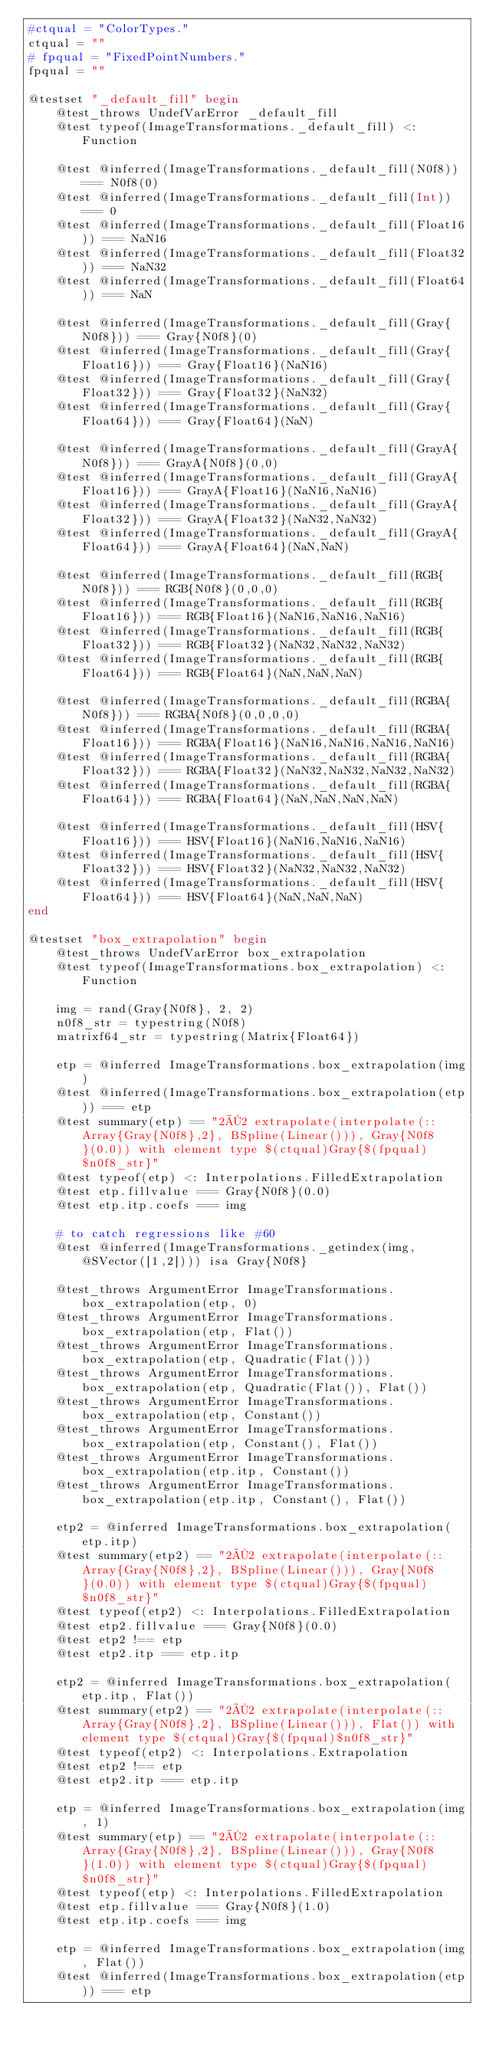<code> <loc_0><loc_0><loc_500><loc_500><_Julia_>#ctqual = "ColorTypes."
ctqual = ""
# fpqual = "FixedPointNumbers."
fpqual = ""

@testset "_default_fill" begin
    @test_throws UndefVarError _default_fill
    @test typeof(ImageTransformations._default_fill) <: Function

    @test @inferred(ImageTransformations._default_fill(N0f8)) === N0f8(0)
    @test @inferred(ImageTransformations._default_fill(Int)) === 0
    @test @inferred(ImageTransformations._default_fill(Float16)) === NaN16
    @test @inferred(ImageTransformations._default_fill(Float32)) === NaN32
    @test @inferred(ImageTransformations._default_fill(Float64)) === NaN

    @test @inferred(ImageTransformations._default_fill(Gray{N0f8})) === Gray{N0f8}(0)
    @test @inferred(ImageTransformations._default_fill(Gray{Float16})) === Gray{Float16}(NaN16)
    @test @inferred(ImageTransformations._default_fill(Gray{Float32})) === Gray{Float32}(NaN32)
    @test @inferred(ImageTransformations._default_fill(Gray{Float64})) === Gray{Float64}(NaN)

    @test @inferred(ImageTransformations._default_fill(GrayA{N0f8})) === GrayA{N0f8}(0,0)
    @test @inferred(ImageTransformations._default_fill(GrayA{Float16})) === GrayA{Float16}(NaN16,NaN16)
    @test @inferred(ImageTransformations._default_fill(GrayA{Float32})) === GrayA{Float32}(NaN32,NaN32)
    @test @inferred(ImageTransformations._default_fill(GrayA{Float64})) === GrayA{Float64}(NaN,NaN)

    @test @inferred(ImageTransformations._default_fill(RGB{N0f8})) === RGB{N0f8}(0,0,0)
    @test @inferred(ImageTransformations._default_fill(RGB{Float16})) === RGB{Float16}(NaN16,NaN16,NaN16)
    @test @inferred(ImageTransformations._default_fill(RGB{Float32})) === RGB{Float32}(NaN32,NaN32,NaN32)
    @test @inferred(ImageTransformations._default_fill(RGB{Float64})) === RGB{Float64}(NaN,NaN,NaN)

    @test @inferred(ImageTransformations._default_fill(RGBA{N0f8})) === RGBA{N0f8}(0,0,0,0)
    @test @inferred(ImageTransformations._default_fill(RGBA{Float16})) === RGBA{Float16}(NaN16,NaN16,NaN16,NaN16)
    @test @inferred(ImageTransformations._default_fill(RGBA{Float32})) === RGBA{Float32}(NaN32,NaN32,NaN32,NaN32)
    @test @inferred(ImageTransformations._default_fill(RGBA{Float64})) === RGBA{Float64}(NaN,NaN,NaN,NaN)

    @test @inferred(ImageTransformations._default_fill(HSV{Float16})) === HSV{Float16}(NaN16,NaN16,NaN16)
    @test @inferred(ImageTransformations._default_fill(HSV{Float32})) === HSV{Float32}(NaN32,NaN32,NaN32)
    @test @inferred(ImageTransformations._default_fill(HSV{Float64})) === HSV{Float64}(NaN,NaN,NaN)
end

@testset "box_extrapolation" begin
    @test_throws UndefVarError box_extrapolation
    @test typeof(ImageTransformations.box_extrapolation) <: Function

    img = rand(Gray{N0f8}, 2, 2)
    n0f8_str = typestring(N0f8)
    matrixf64_str = typestring(Matrix{Float64})

    etp = @inferred ImageTransformations.box_extrapolation(img)
    @test @inferred(ImageTransformations.box_extrapolation(etp)) === etp
    @test summary(etp) == "2×2 extrapolate(interpolate(::Array{Gray{N0f8},2}, BSpline(Linear())), Gray{N0f8}(0.0)) with element type $(ctqual)Gray{$(fpqual)$n0f8_str}"
    @test typeof(etp) <: Interpolations.FilledExtrapolation
    @test etp.fillvalue === Gray{N0f8}(0.0)
    @test etp.itp.coefs === img

    # to catch regressions like #60
    @test @inferred(ImageTransformations._getindex(img, @SVector([1,2]))) isa Gray{N0f8}

    @test_throws ArgumentError ImageTransformations.box_extrapolation(etp, 0)
    @test_throws ArgumentError ImageTransformations.box_extrapolation(etp, Flat())
    @test_throws ArgumentError ImageTransformations.box_extrapolation(etp, Quadratic(Flat()))
    @test_throws ArgumentError ImageTransformations.box_extrapolation(etp, Quadratic(Flat()), Flat())
    @test_throws ArgumentError ImageTransformations.box_extrapolation(etp, Constant())
    @test_throws ArgumentError ImageTransformations.box_extrapolation(etp, Constant(), Flat())
    @test_throws ArgumentError ImageTransformations.box_extrapolation(etp.itp, Constant())
    @test_throws ArgumentError ImageTransformations.box_extrapolation(etp.itp, Constant(), Flat())

    etp2 = @inferred ImageTransformations.box_extrapolation(etp.itp)
    @test summary(etp2) == "2×2 extrapolate(interpolate(::Array{Gray{N0f8},2}, BSpline(Linear())), Gray{N0f8}(0.0)) with element type $(ctqual)Gray{$(fpqual)$n0f8_str}"
    @test typeof(etp2) <: Interpolations.FilledExtrapolation
    @test etp2.fillvalue === Gray{N0f8}(0.0)
    @test etp2 !== etp
    @test etp2.itp === etp.itp

    etp2 = @inferred ImageTransformations.box_extrapolation(etp.itp, Flat())
    @test summary(etp2) == "2×2 extrapolate(interpolate(::Array{Gray{N0f8},2}, BSpline(Linear())), Flat()) with element type $(ctqual)Gray{$(fpqual)$n0f8_str}"
    @test typeof(etp2) <: Interpolations.Extrapolation
    @test etp2 !== etp
    @test etp2.itp === etp.itp

    etp = @inferred ImageTransformations.box_extrapolation(img, 1)
    @test summary(etp) == "2×2 extrapolate(interpolate(::Array{Gray{N0f8},2}, BSpline(Linear())), Gray{N0f8}(1.0)) with element type $(ctqual)Gray{$(fpqual)$n0f8_str}"
    @test typeof(etp) <: Interpolations.FilledExtrapolation
    @test etp.fillvalue === Gray{N0f8}(1.0)
    @test etp.itp.coefs === img

    etp = @inferred ImageTransformations.box_extrapolation(img, Flat())
    @test @inferred(ImageTransformations.box_extrapolation(etp)) === etp</code> 